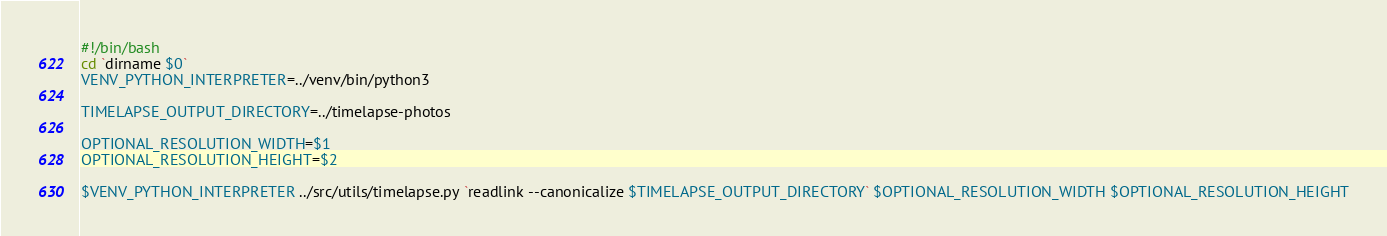<code> <loc_0><loc_0><loc_500><loc_500><_Bash_>#!/bin/bash
cd `dirname $0`
VENV_PYTHON_INTERPRETER=../venv/bin/python3

TIMELAPSE_OUTPUT_DIRECTORY=../timelapse-photos

OPTIONAL_RESOLUTION_WIDTH=$1
OPTIONAL_RESOLUTION_HEIGHT=$2

$VENV_PYTHON_INTERPRETER ../src/utils/timelapse.py `readlink --canonicalize $TIMELAPSE_OUTPUT_DIRECTORY` $OPTIONAL_RESOLUTION_WIDTH $OPTIONAL_RESOLUTION_HEIGHT
</code> 